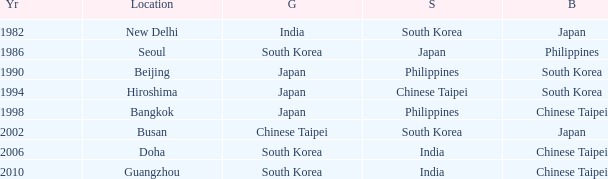Which Location has a Silver of japan? Seoul. Parse the table in full. {'header': ['Yr', 'Location', 'G', 'S', 'B'], 'rows': [['1982', 'New Delhi', 'India', 'South Korea', 'Japan'], ['1986', 'Seoul', 'South Korea', 'Japan', 'Philippines'], ['1990', 'Beijing', 'Japan', 'Philippines', 'South Korea'], ['1994', 'Hiroshima', 'Japan', 'Chinese Taipei', 'South Korea'], ['1998', 'Bangkok', 'Japan', 'Philippines', 'Chinese Taipei'], ['2002', 'Busan', 'Chinese Taipei', 'South Korea', 'Japan'], ['2006', 'Doha', 'South Korea', 'India', 'Chinese Taipei'], ['2010', 'Guangzhou', 'South Korea', 'India', 'Chinese Taipei']]} 